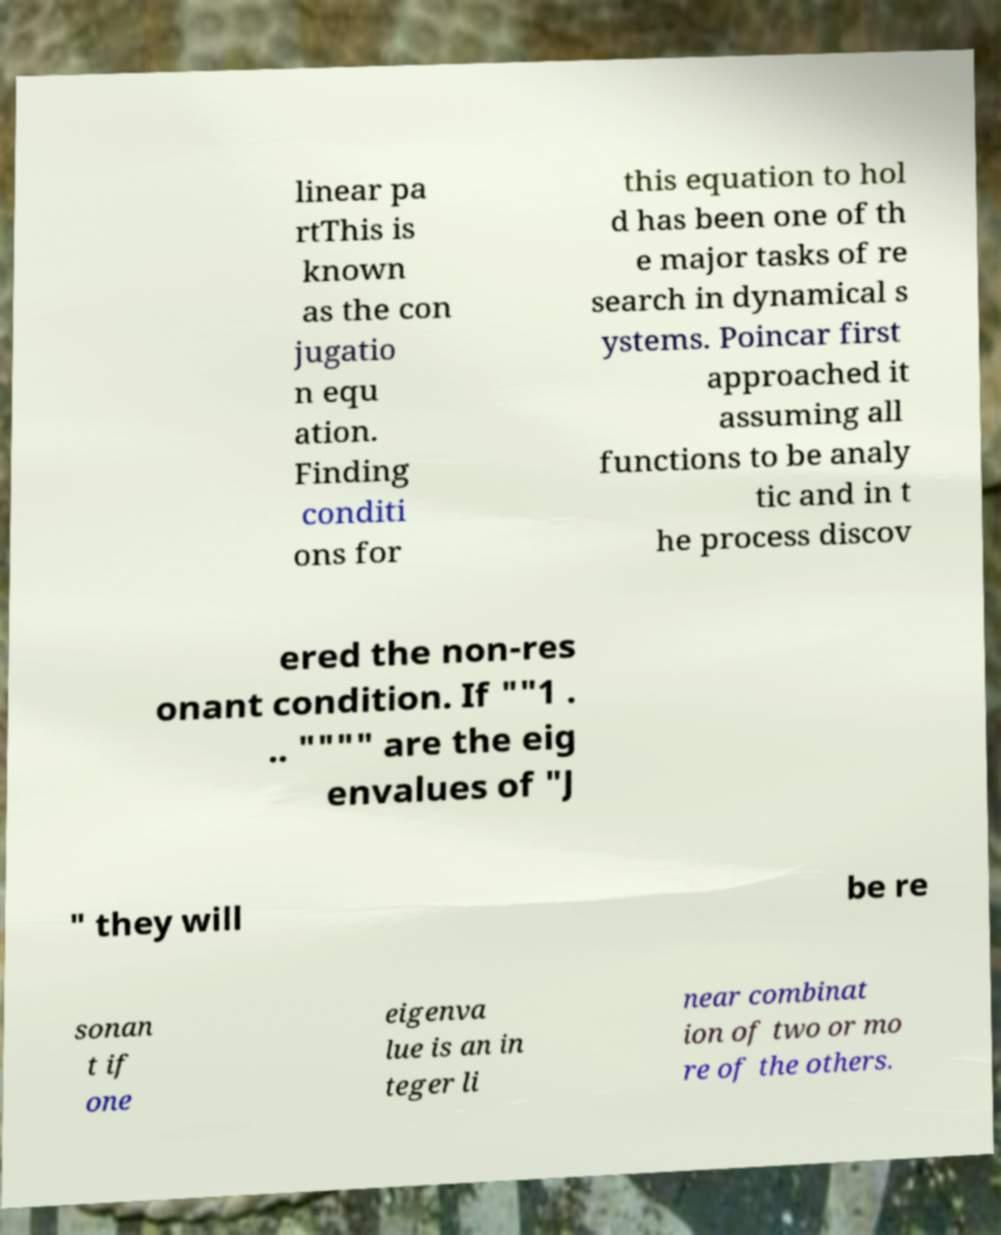Can you accurately transcribe the text from the provided image for me? linear pa rtThis is known as the con jugatio n equ ation. Finding conditi ons for this equation to hol d has been one of th e major tasks of re search in dynamical s ystems. Poincar first approached it assuming all functions to be analy tic and in t he process discov ered the non-res onant condition. If ""1 . .. """" are the eig envalues of "J " they will be re sonan t if one eigenva lue is an in teger li near combinat ion of two or mo re of the others. 